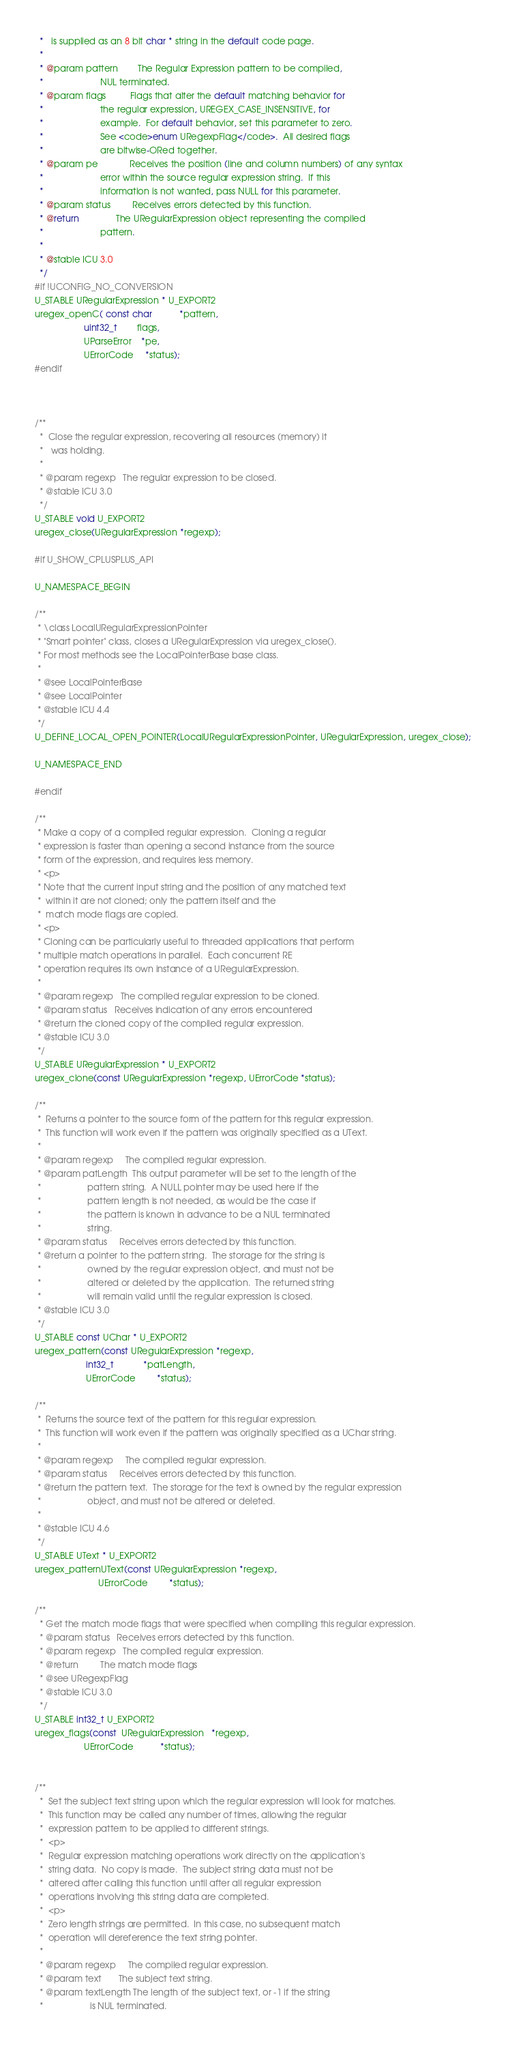<code> <loc_0><loc_0><loc_500><loc_500><_C_>  *   is supplied as an 8 bit char * string in the default code page.
  *
  * @param pattern        The Regular Expression pattern to be compiled, 
  *                       NUL terminated.  
  * @param flags          Flags that alter the default matching behavior for
  *                       the regular expression, UREGEX_CASE_INSENSITIVE, for
  *                       example.  For default behavior, set this parameter to zero.
  *                       See <code>enum URegexpFlag</code>.  All desired flags
  *                       are bitwise-ORed together.
  * @param pe             Receives the position (line and column numbers) of any syntax
  *                       error within the source regular expression string.  If this
  *                       information is not wanted, pass NULL for this parameter.
  * @param status         Receives errors detected by this function.
  * @return               The URegularExpression object representing the compiled
  *                       pattern.
  *
  * @stable ICU 3.0
  */
#if !UCONFIG_NO_CONVERSION
U_STABLE URegularExpression * U_EXPORT2
uregex_openC( const char           *pattern,
                    uint32_t        flags,
                    UParseError    *pe,
                    UErrorCode     *status);
#endif



/**
  *  Close the regular expression, recovering all resources (memory) it
  *   was holding.
  *
  * @param regexp   The regular expression to be closed.
  * @stable ICU 3.0
  */
U_STABLE void U_EXPORT2 
uregex_close(URegularExpression *regexp);

#if U_SHOW_CPLUSPLUS_API

U_NAMESPACE_BEGIN

/**
 * \class LocalURegularExpressionPointer
 * "Smart pointer" class, closes a URegularExpression via uregex_close().
 * For most methods see the LocalPointerBase base class.
 *
 * @see LocalPointerBase
 * @see LocalPointer
 * @stable ICU 4.4
 */
U_DEFINE_LOCAL_OPEN_POINTER(LocalURegularExpressionPointer, URegularExpression, uregex_close);

U_NAMESPACE_END

#endif

/**
 * Make a copy of a compiled regular expression.  Cloning a regular
 * expression is faster than opening a second instance from the source
 * form of the expression, and requires less memory.
 * <p>
 * Note that the current input string and the position of any matched text
 *  within it are not cloned; only the pattern itself and the
 *  match mode flags are copied.
 * <p>
 * Cloning can be particularly useful to threaded applications that perform
 * multiple match operations in parallel.  Each concurrent RE
 * operation requires its own instance of a URegularExpression.
 *
 * @param regexp   The compiled regular expression to be cloned.
 * @param status   Receives indication of any errors encountered
 * @return the cloned copy of the compiled regular expression.
 * @stable ICU 3.0
 */
U_STABLE URegularExpression * U_EXPORT2 
uregex_clone(const URegularExpression *regexp, UErrorCode *status);

/**
 *  Returns a pointer to the source form of the pattern for this regular expression.
 *  This function will work even if the pattern was originally specified as a UText.
 *
 * @param regexp     The compiled regular expression.
 * @param patLength  This output parameter will be set to the length of the
 *                   pattern string.  A NULL pointer may be used here if the
 *                   pattern length is not needed, as would be the case if
 *                   the pattern is known in advance to be a NUL terminated
 *                   string.
 * @param status     Receives errors detected by this function.
 * @return a pointer to the pattern string.  The storage for the string is
 *                   owned by the regular expression object, and must not be
 *                   altered or deleted by the application.  The returned string
 *                   will remain valid until the regular expression is closed.
 * @stable ICU 3.0
 */
U_STABLE const UChar * U_EXPORT2 
uregex_pattern(const URegularExpression *regexp,
                     int32_t            *patLength,
                     UErrorCode         *status);

/**
 *  Returns the source text of the pattern for this regular expression.
 *  This function will work even if the pattern was originally specified as a UChar string.
 *
 * @param regexp     The compiled regular expression.
 * @param status     Receives errors detected by this function.
 * @return the pattern text.  The storage for the text is owned by the regular expression
 *                   object, and must not be altered or deleted.
 *
 * @stable ICU 4.6
 */
U_STABLE UText * U_EXPORT2 
uregex_patternUText(const URegularExpression *regexp,
                          UErrorCode         *status);

/**
  * Get the match mode flags that were specified when compiling this regular expression.
  * @param status   Receives errors detected by this function.
  * @param regexp   The compiled regular expression.
  * @return         The match mode flags
  * @see URegexpFlag
  * @stable ICU 3.0
  */
U_STABLE int32_t U_EXPORT2 
uregex_flags(const  URegularExpression   *regexp,
                    UErrorCode           *status);


/**
  *  Set the subject text string upon which the regular expression will look for matches.
  *  This function may be called any number of times, allowing the regular
  *  expression pattern to be applied to different strings.
  *  <p>
  *  Regular expression matching operations work directly on the application's
  *  string data.  No copy is made.  The subject string data must not be
  *  altered after calling this function until after all regular expression
  *  operations involving this string data are completed.  
  *  <p>
  *  Zero length strings are permitted.  In this case, no subsequent match
  *  operation will dereference the text string pointer.
  *
  * @param regexp     The compiled regular expression.
  * @param text       The subject text string.
  * @param textLength The length of the subject text, or -1 if the string
  *                   is NUL terminated.</code> 